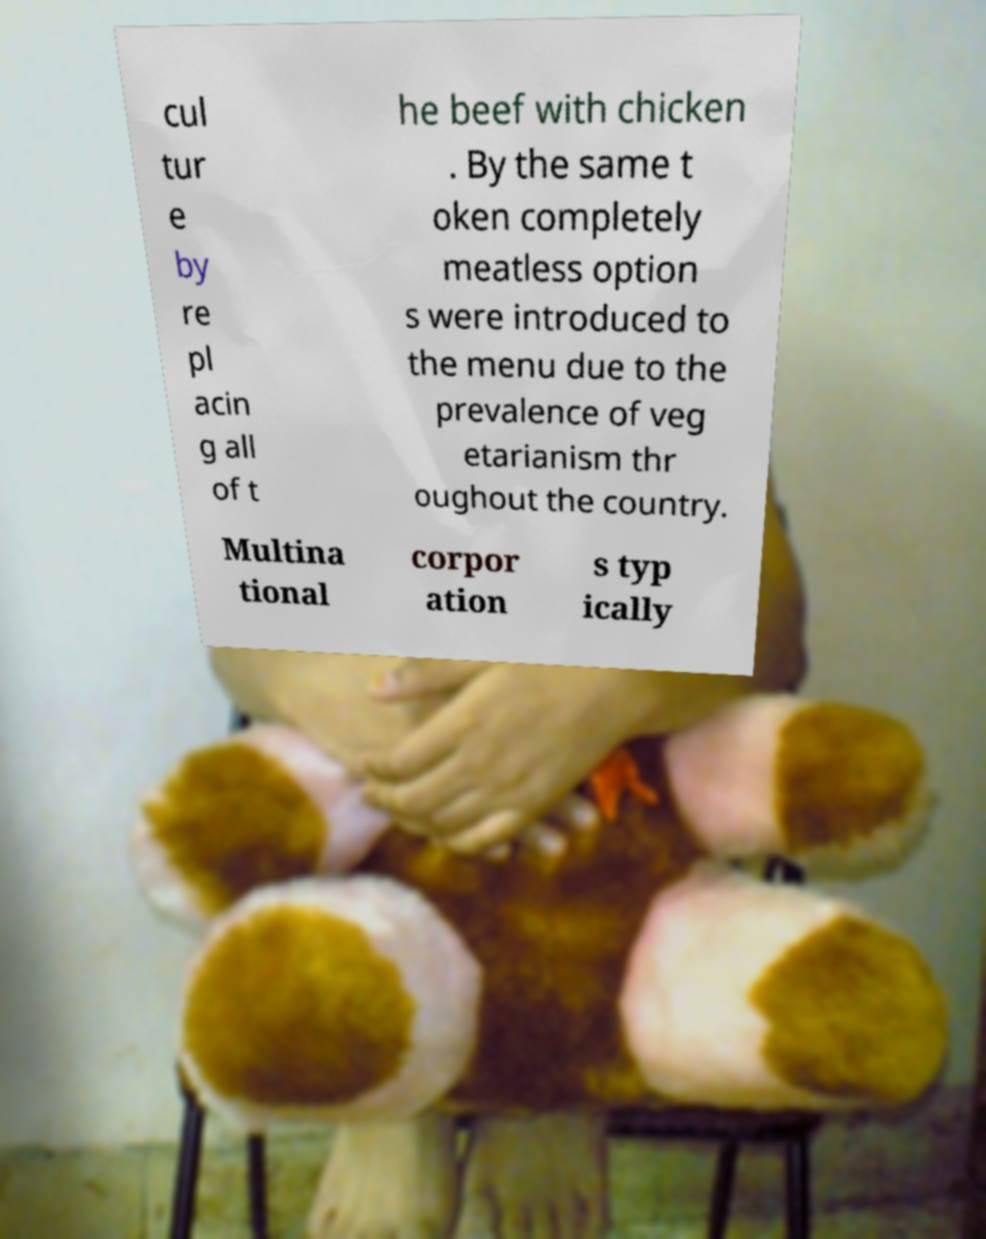Can you read and provide the text displayed in the image?This photo seems to have some interesting text. Can you extract and type it out for me? cul tur e by re pl acin g all of t he beef with chicken . By the same t oken completely meatless option s were introduced to the menu due to the prevalence of veg etarianism thr oughout the country. Multina tional corpor ation s typ ically 